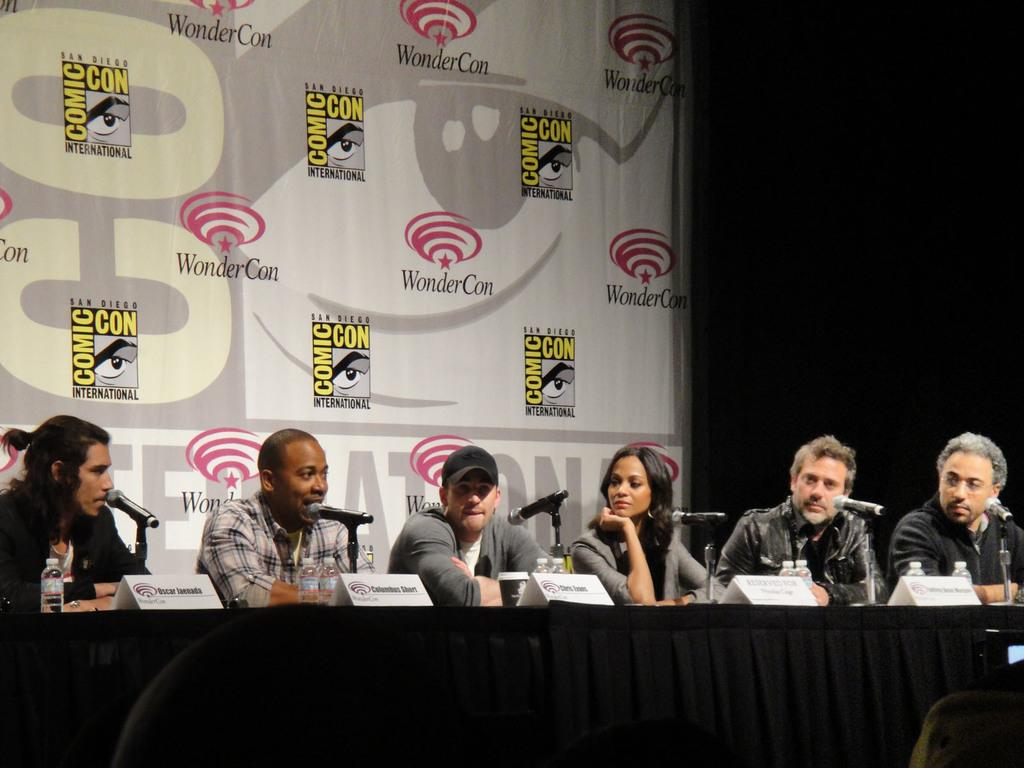What is happening with the people in the image? The people are sitting behind a table. What is on the table with the people? There are mice, name plates, and bottles on the table. What can be seen in the background of the image? There is a banner in the background. What type of animal is quivering in the image? There are no animals quivering in the image. What is the time of day depicted in the image? The time of day is not mentioned in the provided facts, so it cannot be determined from the image. 